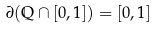Convert formula to latex. <formula><loc_0><loc_0><loc_500><loc_500>\partial ( \mathbb { Q } \cap [ 0 , 1 ] ) = [ 0 , 1 ]</formula> 